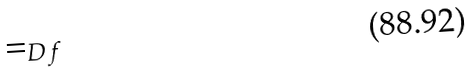Convert formula to latex. <formula><loc_0><loc_0><loc_500><loc_500>= _ { D f }</formula> 